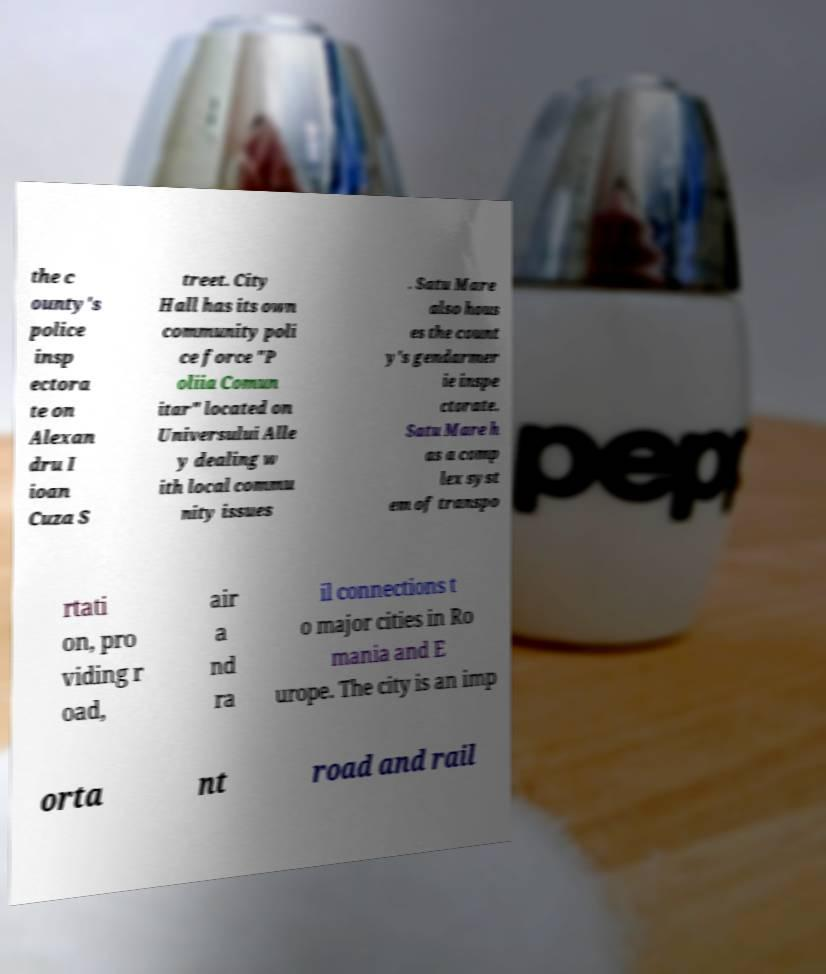Can you read and provide the text displayed in the image?This photo seems to have some interesting text. Can you extract and type it out for me? the c ounty's police insp ectora te on Alexan dru I ioan Cuza S treet. City Hall has its own community poli ce force "P oliia Comun itar" located on Universului Alle y dealing w ith local commu nity issues . Satu Mare also hous es the count y's gendarmer ie inspe ctorate. Satu Mare h as a comp lex syst em of transpo rtati on, pro viding r oad, air a nd ra il connections t o major cities in Ro mania and E urope. The city is an imp orta nt road and rail 